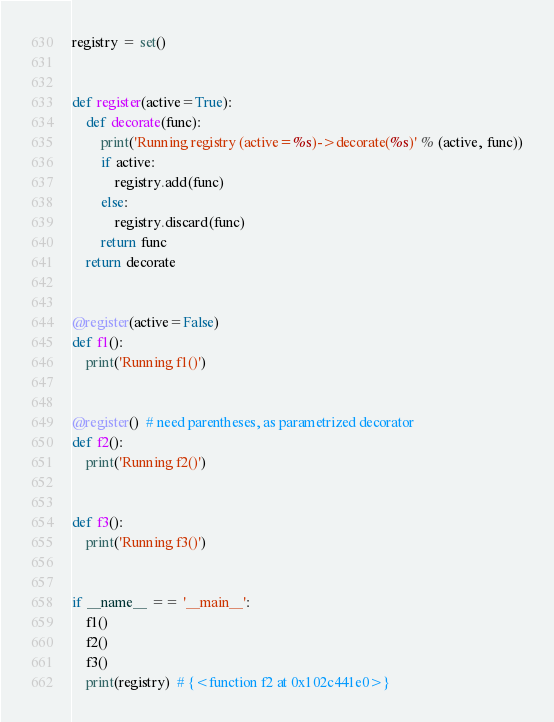Convert code to text. <code><loc_0><loc_0><loc_500><loc_500><_Python_>registry = set()


def register(active=True):
    def decorate(func):
        print('Running registry (active=%s)->decorate(%s)' % (active, func))
        if active:
            registry.add(func)
        else:
            registry.discard(func)
        return func
    return decorate


@register(active=False)
def f1():
    print('Running f1()')


@register()  # need parentheses, as parametrized decorator
def f2():
    print('Running f2()')


def f3():
    print('Running f3()')


if __name__ == '__main__':
    f1()
    f2()
    f3()
    print(registry)  # {<function f2 at 0x102c441e0>}
</code> 